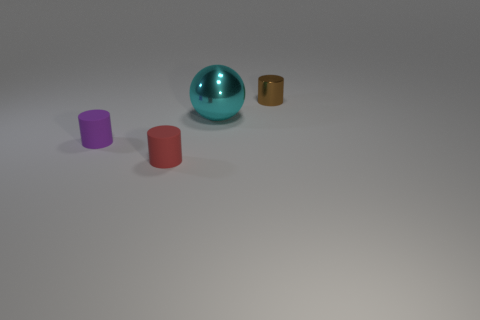Add 3 shiny balls. How many objects exist? 7 Subtract all spheres. How many objects are left? 3 Subtract 1 purple cylinders. How many objects are left? 3 Subtract all small red rubber things. Subtract all small brown cylinders. How many objects are left? 2 Add 4 small purple matte cylinders. How many small purple matte cylinders are left? 5 Add 2 green matte things. How many green matte things exist? 2 